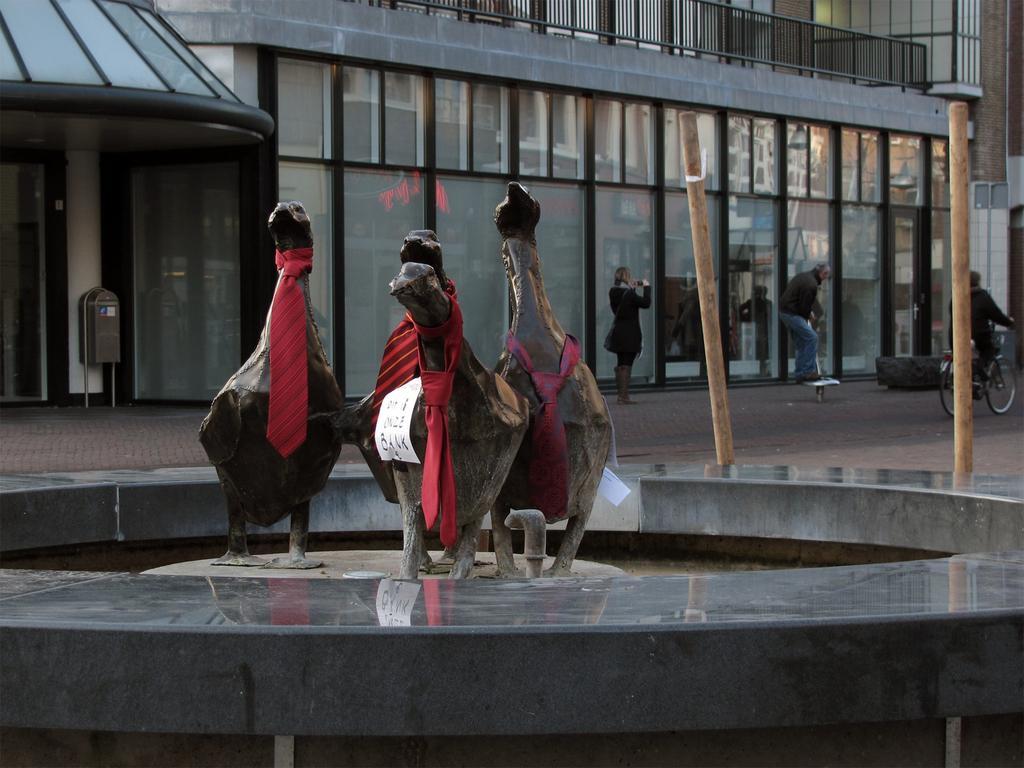Please provide a concise description of this image. In the center of the image we can see statues and wearing tie and also we can see papers. In the background of the image we can see buildings, door, wall, grills, some persons, poles, bag, bicycle, ground. 